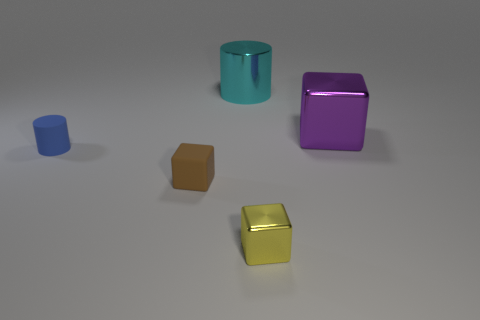Add 1 blue cylinders. How many objects exist? 6 Subtract all blocks. How many objects are left? 2 Subtract all small green rubber spheres. Subtract all cyan things. How many objects are left? 4 Add 4 big shiny blocks. How many big shiny blocks are left? 5 Add 5 red metallic balls. How many red metallic balls exist? 5 Subtract 0 brown balls. How many objects are left? 5 